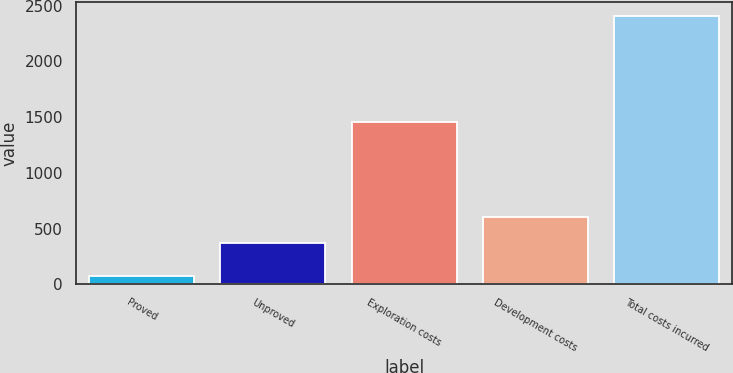Convert chart to OTSL. <chart><loc_0><loc_0><loc_500><loc_500><bar_chart><fcel>Proved<fcel>Unproved<fcel>Exploration costs<fcel>Development costs<fcel>Total costs incurred<nl><fcel>78<fcel>368<fcel>1454<fcel>601.1<fcel>2409<nl></chart> 